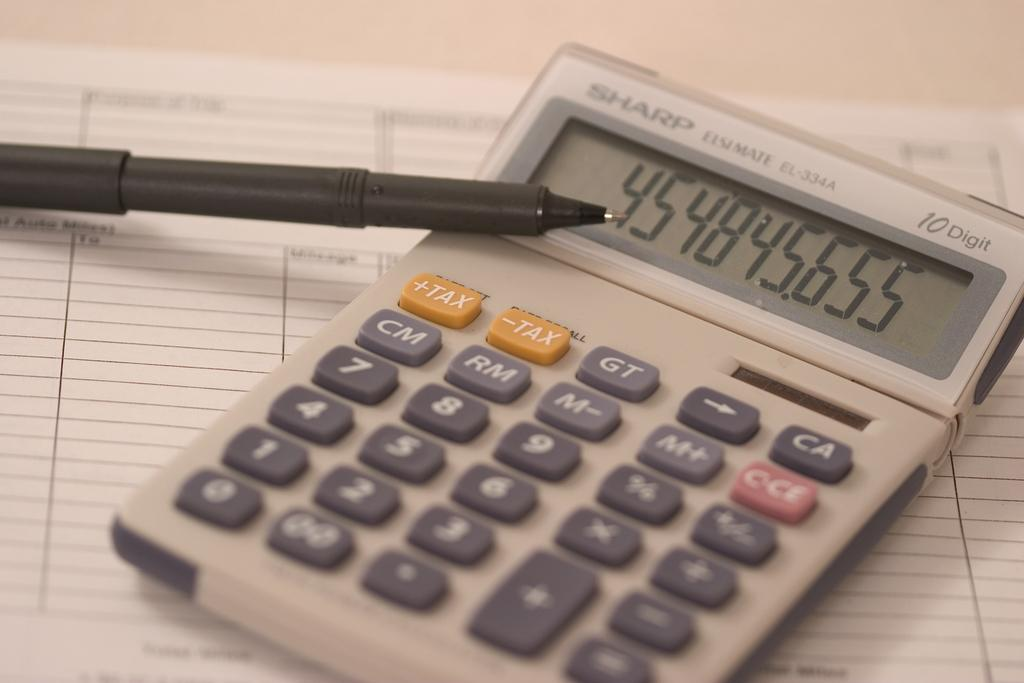What is on the table in the image? There is a paper, a black color pen, and a calculator on the table. What can be used for writing in the image? A black color pen can be used for writing in the image. What device is present on the table that can perform mathematical calculations? There is a calculator on the table that can perform mathematical calculations. What type of corn is growing in the image? There is no corn present in the image; it features a table with a paper, a black color pen, and a calculator. 